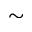Convert formula to latex. <formula><loc_0><loc_0><loc_500><loc_500>\sim</formula> 